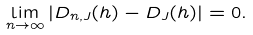<formula> <loc_0><loc_0><loc_500><loc_500>\lim _ { n \rightarrow \infty } | D _ { n , J } ( h ) - D _ { J } ( h ) | = 0 .</formula> 